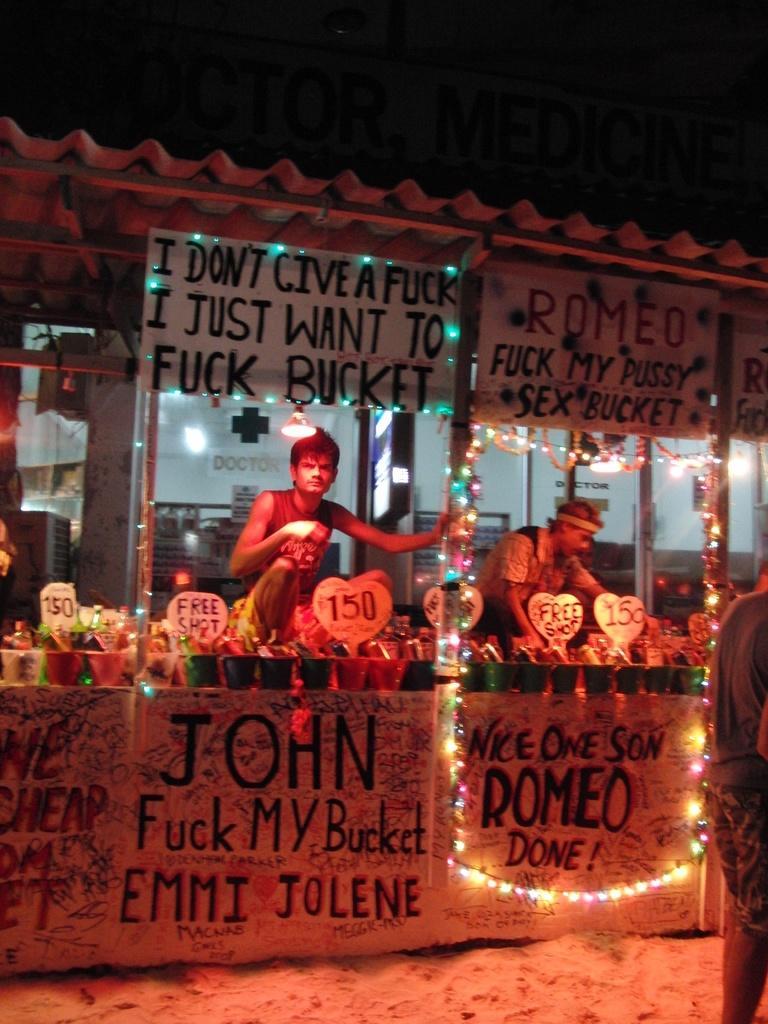Please provide a concise description of this image. In this image we can see a stall which contains board and text written in it and a person sitting and some lights attached to the stall. There are some objects on the table and a person standing in front of the stall. 